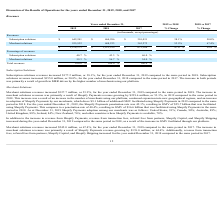According to Shopify's financial document, What is the total revenue for year ended December 31, 2019? According to the financial document, $1,578,173 (in thousands). The relevant text states: "$ 1,578,173 $ 1,073,229 $ 673,304 47.0 % 59.4 %..." Also, What is the subscription solutions revenue for year ended December 31, 2019? According to the financial document, $642,241 (in thousands). The relevant text states: "Subscription solutions $ 642,241 $ 464,996 $ 310,031 38.1% 50.0%..." Also, What is the merchant solutions revenue for year ended December 31, 2019? According to the financial document, 935,932 (in thousands). The relevant text states: "Merchant solutions 935,932 608,233 363,273 53.9% 67.4%..." Additionally, Which year has the highest Subscription solutions revenues? According to the financial document, 2019. The relevant text states: "Years ended December 31, 2019 vs 2018 2018 vs 2017..." Additionally, Which year has the highest Merchant solutions revenues? According to the financial document, 2019. The relevant text states: "Years ended December 31, 2019 vs 2018 2018 vs 2017..." Also, can you calculate: What is the change in subscription solutions revenue between 2018 and 2019? Based on the calculation: 642,241-464,996, the result is 177245 (in thousands). This is based on the information: "Subscription solutions $ 642,241 $ 464,996 $ 310,031 38.1% 50.0% Subscription solutions $ 642,241 $ 464,996 $ 310,031 38.1% 50.0%..." The key data points involved are: 464,996, 642,241. 